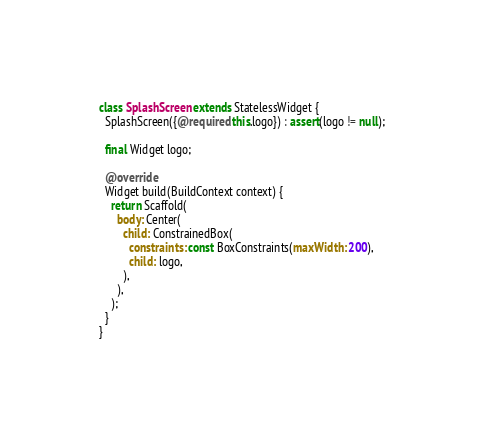<code> <loc_0><loc_0><loc_500><loc_500><_Dart_>
class SplashScreen extends StatelessWidget {
  SplashScreen({@required this.logo}) : assert(logo != null);

  final Widget logo;

  @override
  Widget build(BuildContext context) {
    return Scaffold(
      body: Center(
        child: ConstrainedBox(
          constraints: const BoxConstraints(maxWidth: 200),
          child: logo,
        ),
      ),
    );
  }
}
</code> 